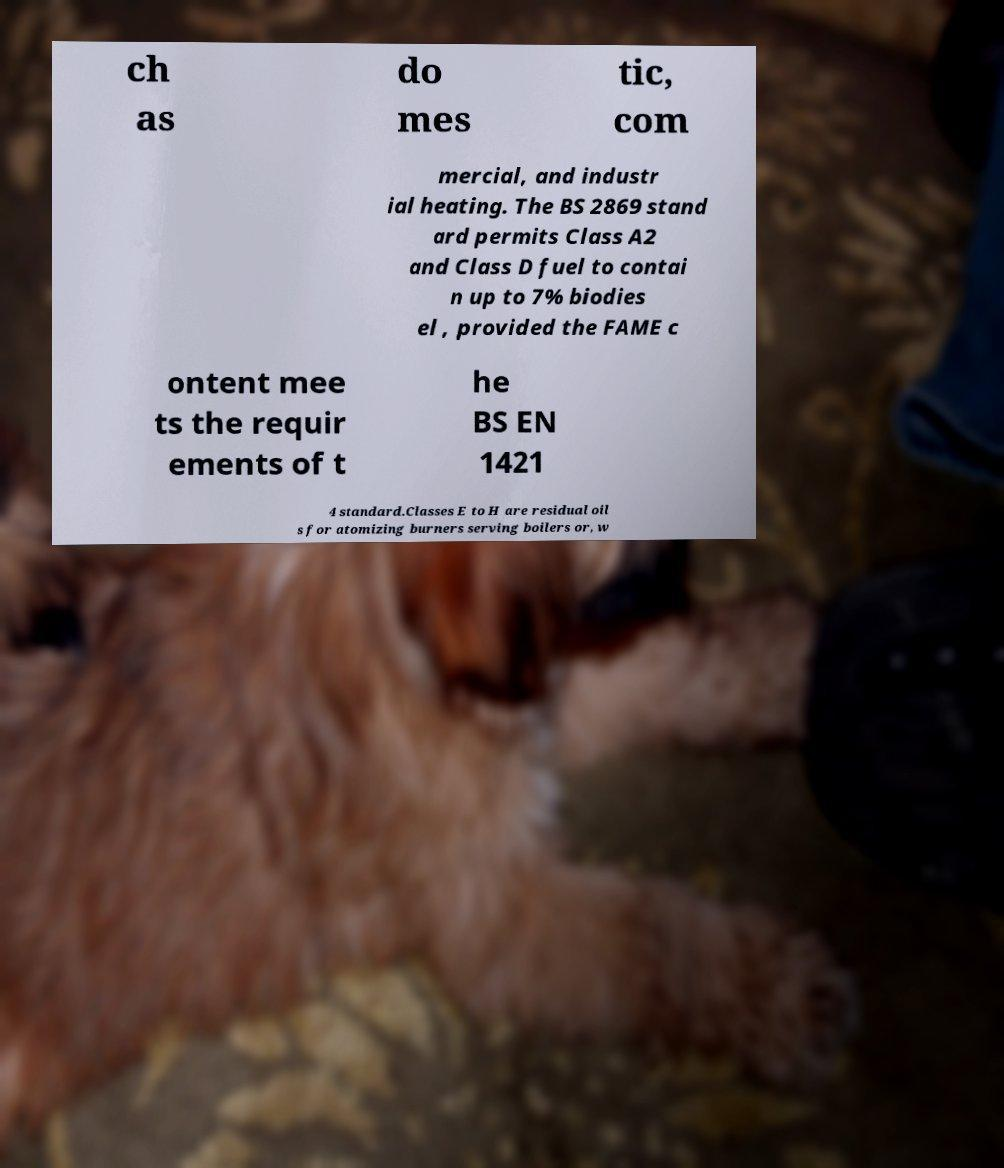Please identify and transcribe the text found in this image. ch as do mes tic, com mercial, and industr ial heating. The BS 2869 stand ard permits Class A2 and Class D fuel to contai n up to 7% biodies el , provided the FAME c ontent mee ts the requir ements of t he BS EN 1421 4 standard.Classes E to H are residual oil s for atomizing burners serving boilers or, w 